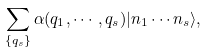Convert formula to latex. <formula><loc_0><loc_0><loc_500><loc_500>\sum _ { \{ q _ { s } \} } \alpha ( q _ { 1 } , \cdots , q _ { s } ) | n _ { 1 } \cdots n _ { s } \rangle ,</formula> 